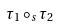Convert formula to latex. <formula><loc_0><loc_0><loc_500><loc_500>\tau _ { 1 } \circ _ { s } \tau _ { 2 }</formula> 